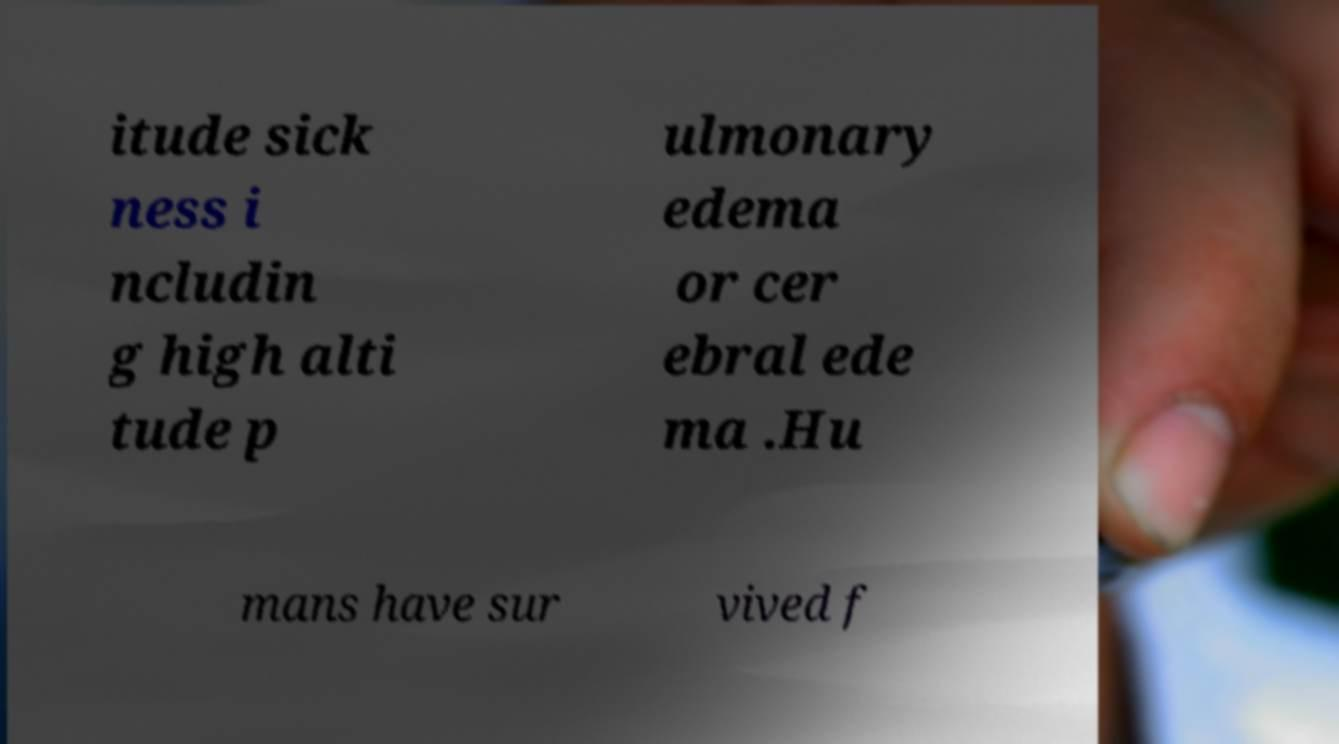What messages or text are displayed in this image? I need them in a readable, typed format. itude sick ness i ncludin g high alti tude p ulmonary edema or cer ebral ede ma .Hu mans have sur vived f 